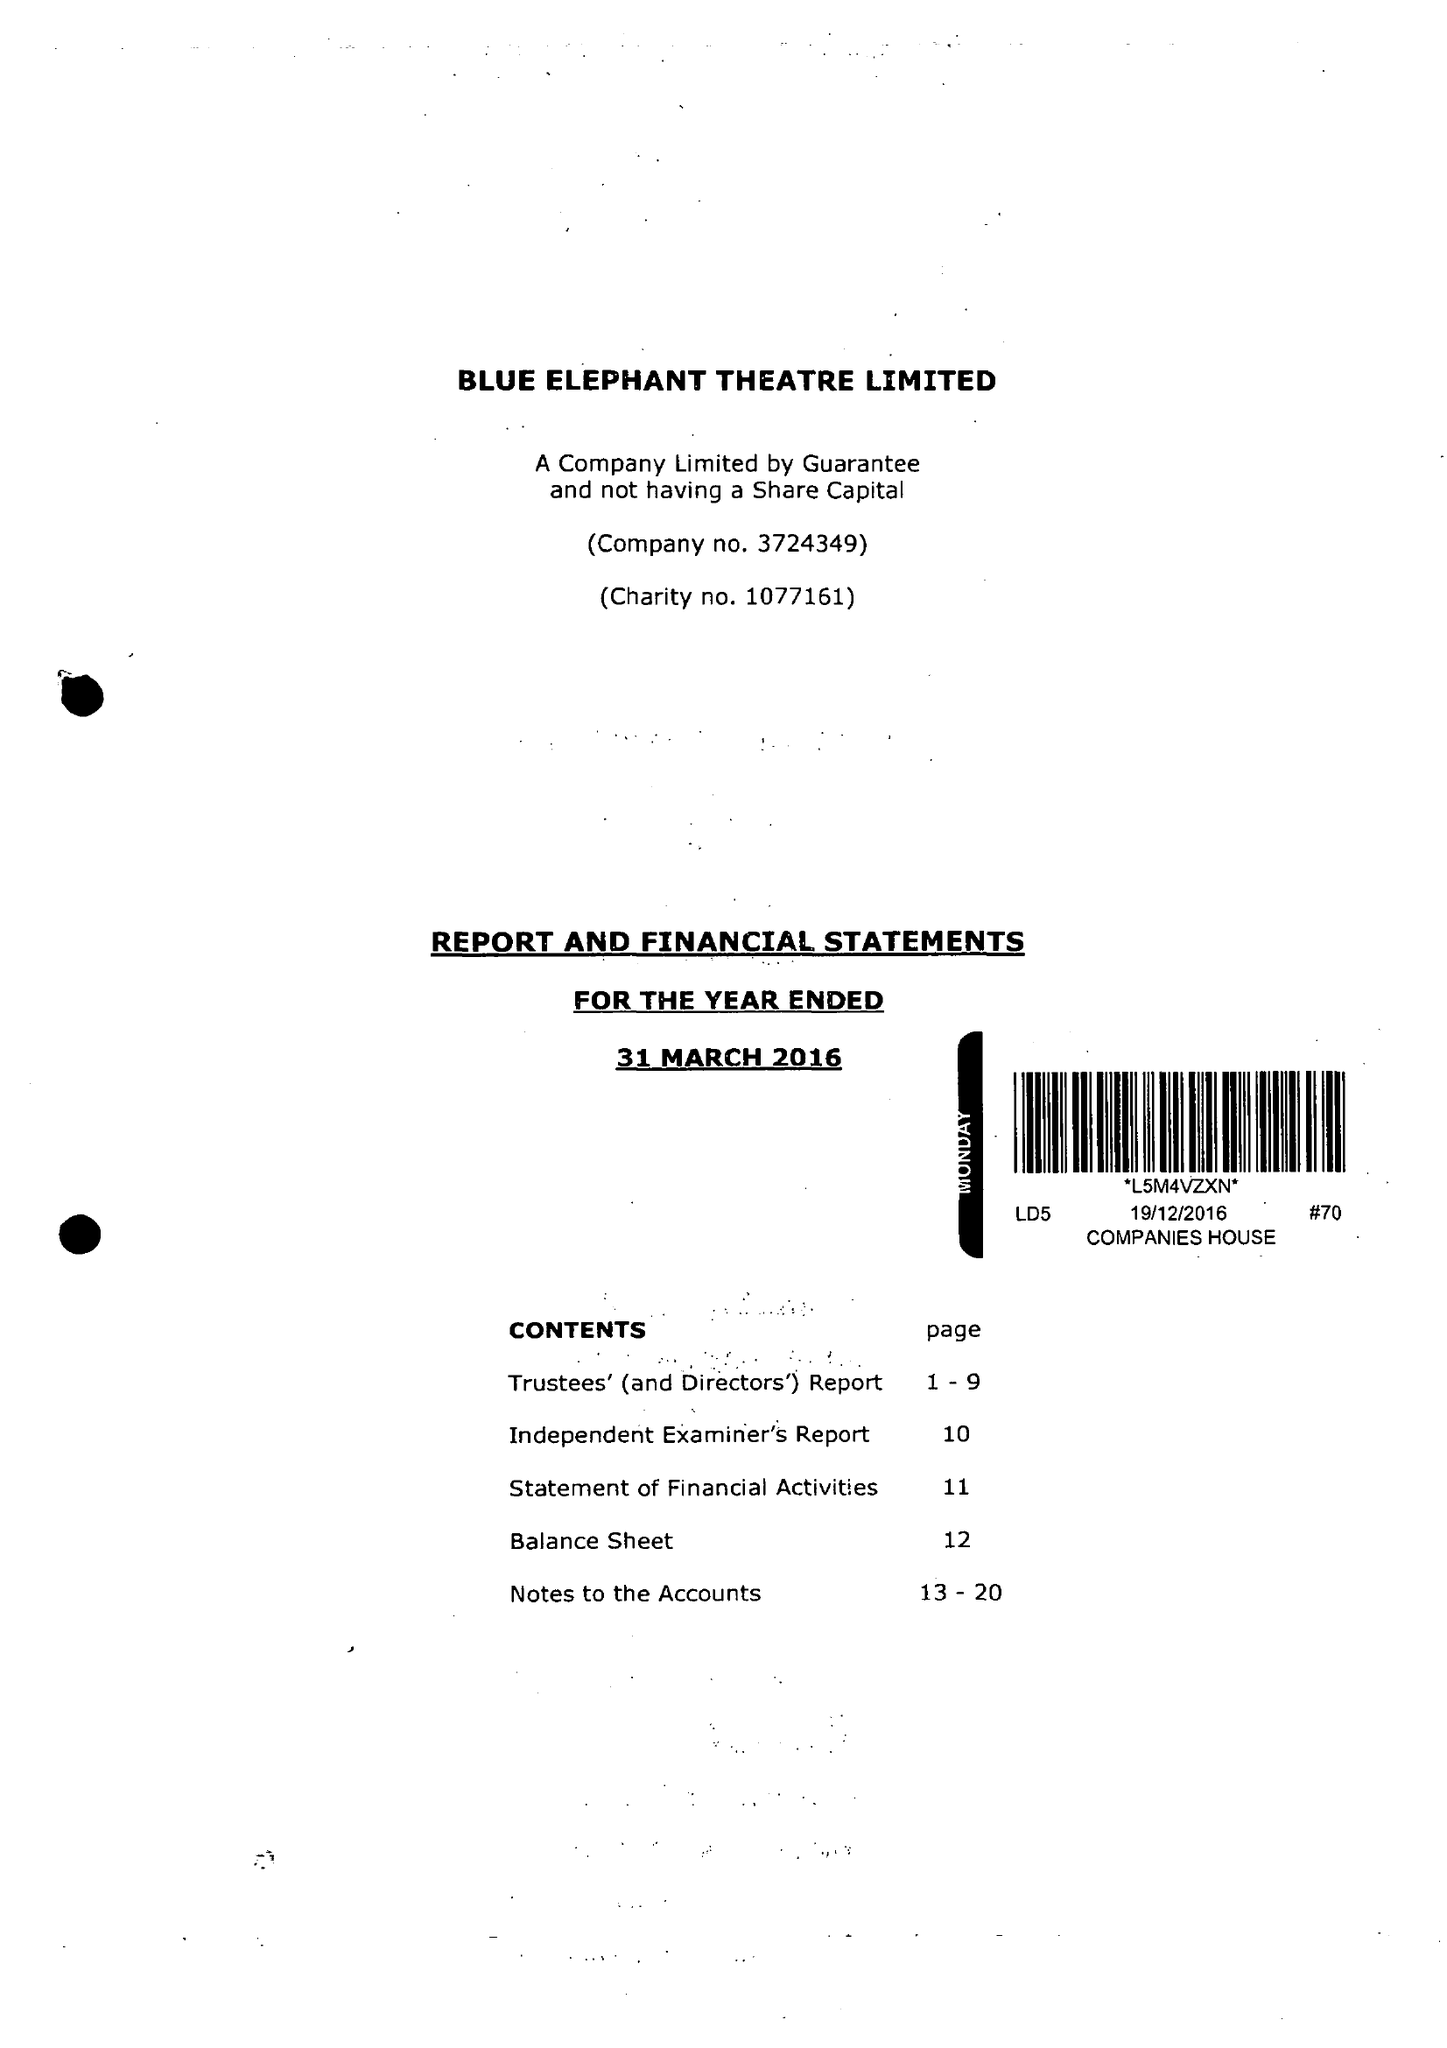What is the value for the report_date?
Answer the question using a single word or phrase. 2016-03-31 